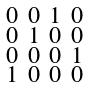Convert formula to latex. <formula><loc_0><loc_0><loc_500><loc_500>\begin{smallmatrix} 0 & 0 & 1 & 0 \\ 0 & 1 & 0 & 0 \\ 0 & 0 & 0 & 1 \\ 1 & 0 & 0 & 0 \end{smallmatrix}</formula> 